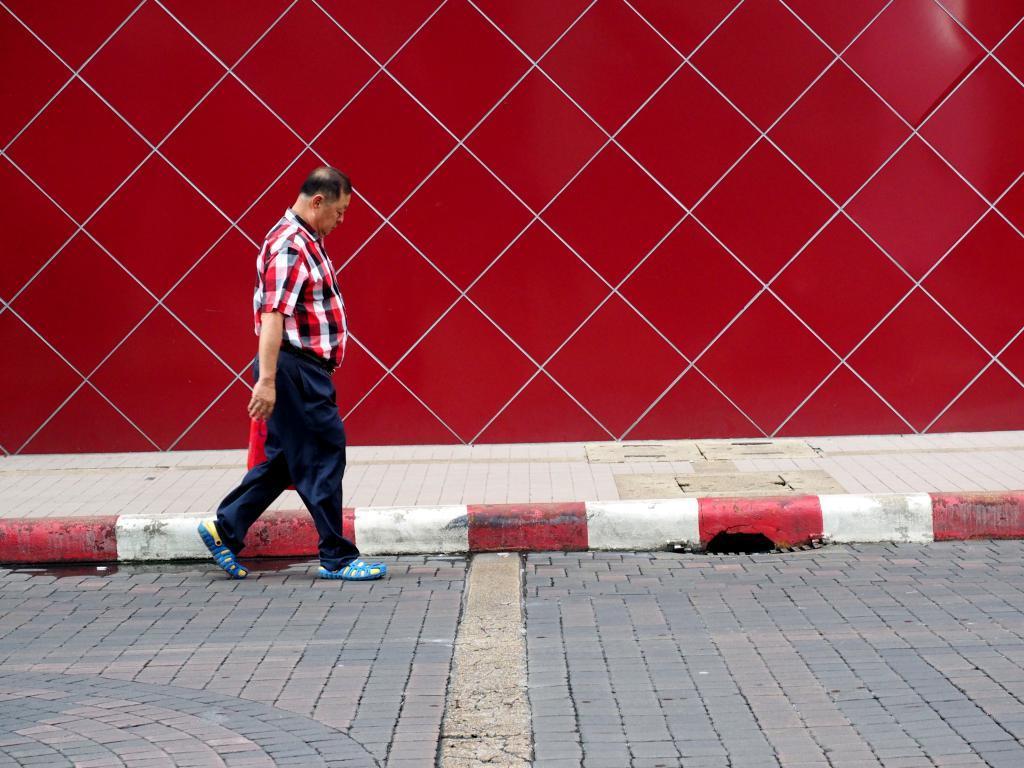How would you summarize this image in a sentence or two? In this picture we can see a person walking on the ground and in the background we can see red color. 